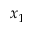Convert formula to latex. <formula><loc_0><loc_0><loc_500><loc_500>x _ { 1 }</formula> 